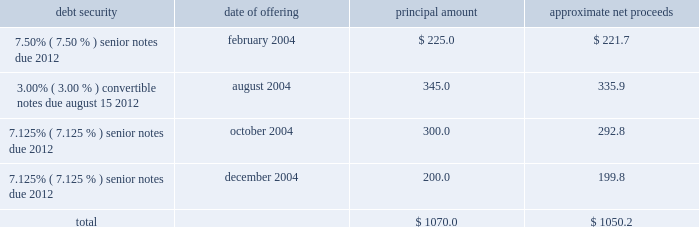Proceeds from the sale of equity securities .
From time to time , we raise funds through public offerings of our equity securities .
In addition , we receive proceeds from sales of our equity securities pursuant to our stock option and stock purchase plans .
For the year ended december 31 , 2004 , we received approximately $ 40.6 million in proceeds from sales of shares of our class a common stock and the common stock of atc mexico pursuant to our stock option and stock purchase plans .
Financing activities during the year ended december 31 , 2004 , we took several actions to increase our financial flexibility and reduce our interest costs .
New credit facility .
In may 2004 , we refinanced our previous credit facility with a new $ 1.1 billion senior secured credit facility .
At closing , we received $ 685.5 million of net proceeds from the borrowings under the new facility , after deducting related expenses and fees , approximately $ 670.0 million of which we used to repay principal and interest under the previous credit facility .
We used the remaining net proceeds of $ 15.5 million for general corporate purposes , including the repurchase of other outstanding debt securities .
The new credit facility consists of the following : 2022 $ 400.0 million in undrawn revolving loan commitments , against which approximately $ 19.3 million of undrawn letters of credit were outstanding at december 31 , 2004 , maturing on february 28 , 2011 ; 2022 a $ 300.0 million term loan a , which is fully drawn , maturing on february 28 , 2011 ; and 2022 a $ 398.0 million term loan b , which is fully drawn , maturing on august 31 , 2011 .
The new credit facility extends the previous credit facility maturity dates from 2007 to 2011 for a majority of the borrowings outstanding , subject to earlier maturity upon the occurrence of certain events described below , and allows us to use credit facility borrowings and internally generated funds to repurchase other indebtedness without additional lender approval .
The new credit facility is guaranteed by us and is secured by a pledge of substantially all of our assets .
The maturity date for term loan a and any outstanding revolving loans will be accelerated to august 15 , 2008 , and the maturity date for term loan b will be accelerated to october 31 , 2008 , if ( 1 ) on or prior to august 1 , 2008 , our 93 20448% ( 20448 % ) senior notes have not been ( a ) refinanced with parent company indebtedness having a maturity date of february 28 , 2012 or later or with loans under the new credit facility , or ( b ) repaid , prepaid , redeemed , repurchased or otherwise retired , and ( 2 ) our consolidated leverage ratio ( total parent company debt to annualized operating cash flow ) at june 30 , 2008 is greater than 4.50 to 1.00 .
If this were to occur , the payments due in 2008 for term loan a and term loan b would be $ 225.0 million and $ 386.0 million , respectively .
Note offerings .
During 2004 , we raised approximately $ 1.1 billion in net proceeds from the sale of debt securities through institutional private placements as follows ( in millions ) : debt security date of offering principal amount approximate net proceeds .
2022 7.50% ( 7.50 % ) senior notes offering .
In february 2004 , we sold $ 225.0 million principal amount of our 7.50% ( 7.50 % ) senior notes due 2012 through an institutional private placement .
The 7.50% ( 7.50 % ) senior notes mature on may 1 , 2012 , and interest is payable semiannually in arrears on may 1 and november 1 of each year. .
What was the percent of the processing fees and expenses associated with the loan facility pen in may 2004? 
Computations: ((685.5 - 670.0) / 670.0)
Answer: 0.02313. 